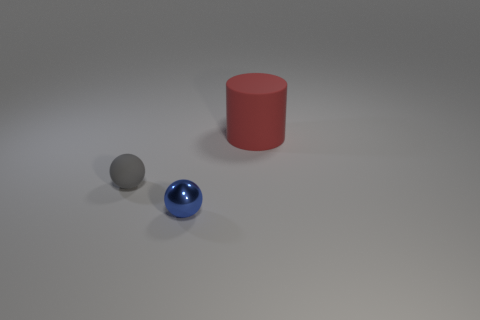Are there any other things that are made of the same material as the small blue ball?
Provide a short and direct response. No. Are the gray sphere and the sphere to the right of the gray ball made of the same material?
Offer a very short reply. No. What is the color of the tiny metal sphere?
Your answer should be compact. Blue. How many metal spheres are behind the matte object right of the sphere behind the small blue sphere?
Offer a very short reply. 0. There is a red rubber cylinder; are there any small gray matte objects in front of it?
Offer a terse response. Yes. What number of small blue cylinders are made of the same material as the red object?
Ensure brevity in your answer.  0. How many objects are either cyan matte balls or gray spheres?
Keep it short and to the point. 1. Are there any big red cylinders?
Provide a short and direct response. Yes. What is the material of the small ball on the left side of the small sphere that is to the right of the matte thing in front of the matte cylinder?
Give a very brief answer. Rubber. Are there fewer matte cylinders that are in front of the gray matte sphere than large rubber things?
Keep it short and to the point. Yes. 